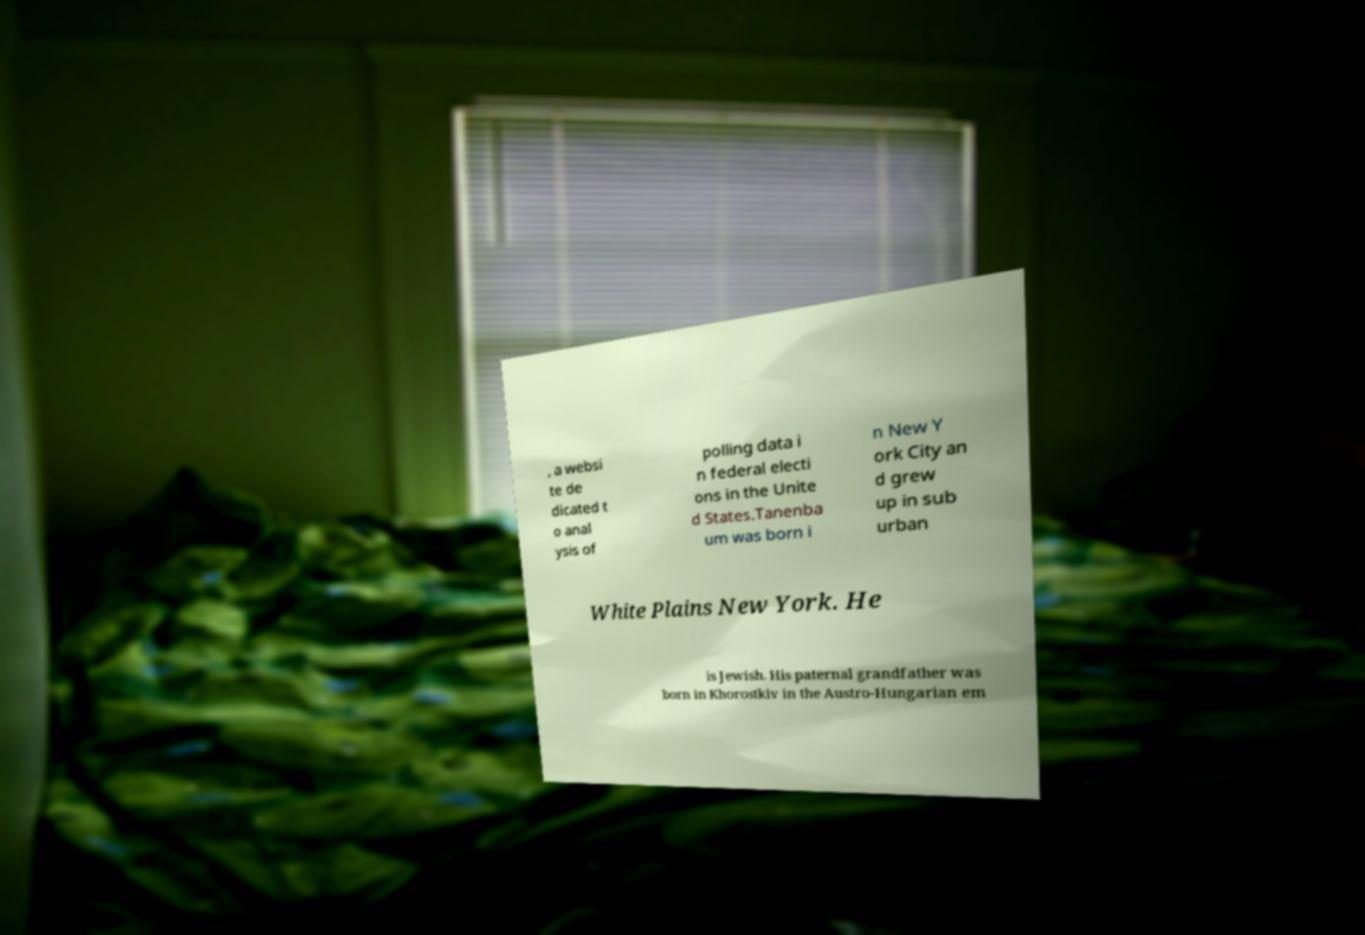Can you accurately transcribe the text from the provided image for me? , a websi te de dicated t o anal ysis of polling data i n federal electi ons in the Unite d States.Tanenba um was born i n New Y ork City an d grew up in sub urban White Plains New York. He is Jewish. His paternal grandfather was born in Khorostkiv in the Austro-Hungarian em 